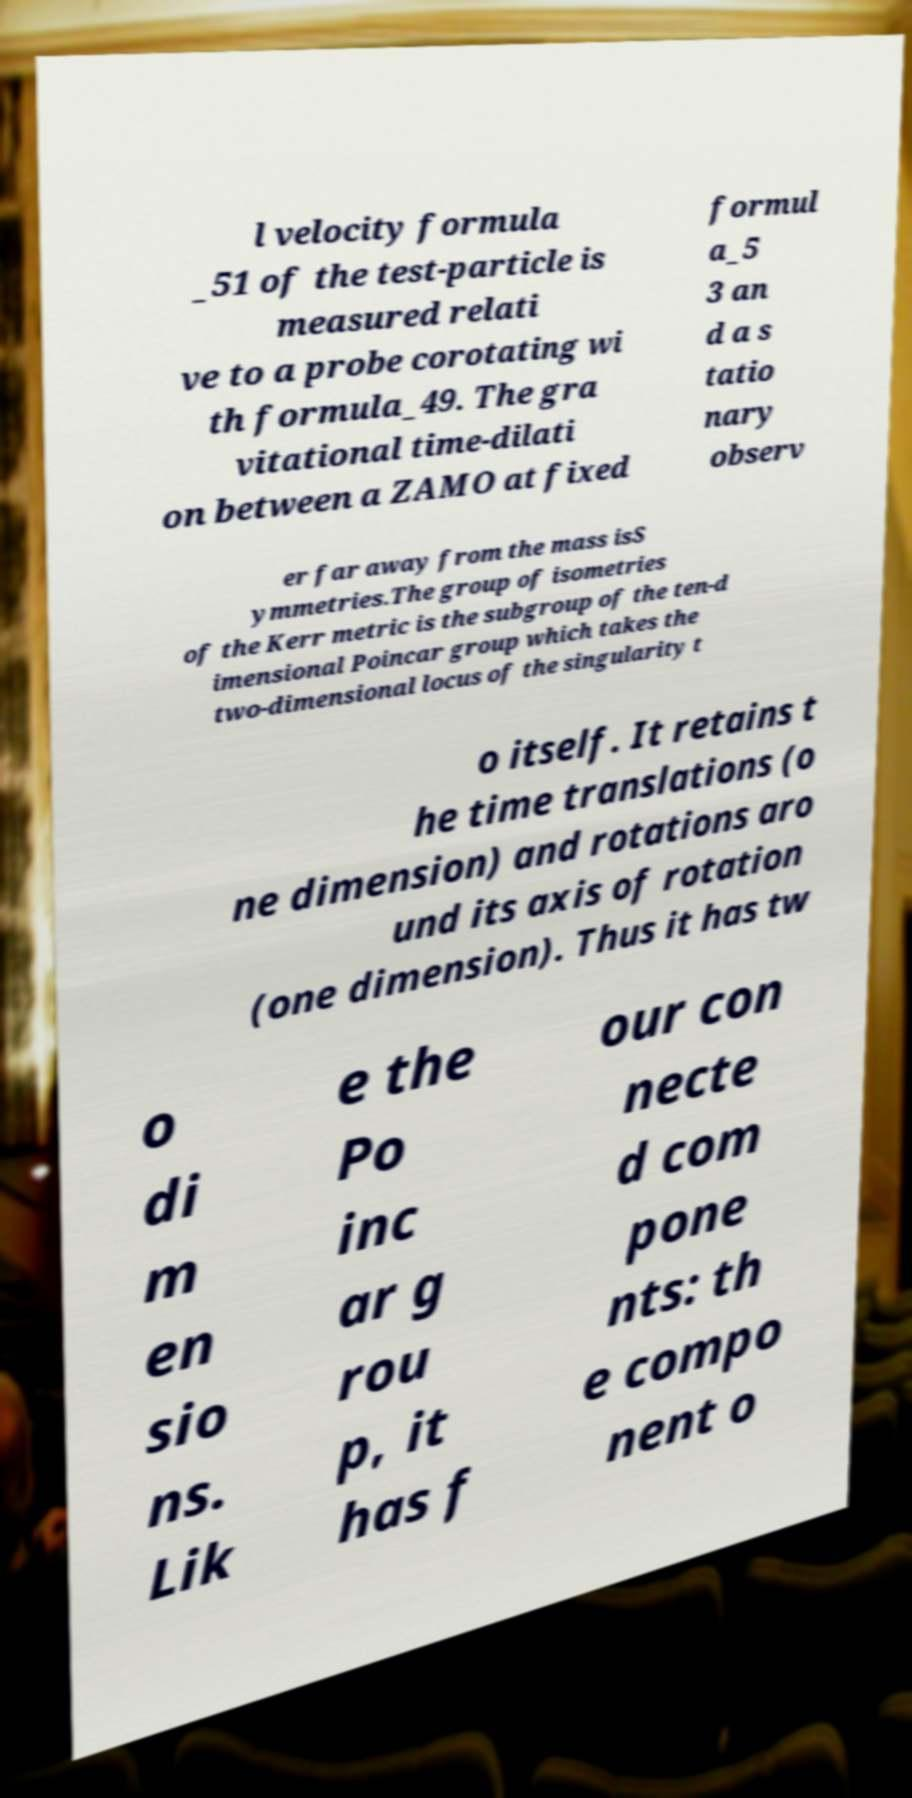Can you read and provide the text displayed in the image?This photo seems to have some interesting text. Can you extract and type it out for me? l velocity formula _51 of the test-particle is measured relati ve to a probe corotating wi th formula_49. The gra vitational time-dilati on between a ZAMO at fixed formul a_5 3 an d a s tatio nary observ er far away from the mass isS ymmetries.The group of isometries of the Kerr metric is the subgroup of the ten-d imensional Poincar group which takes the two-dimensional locus of the singularity t o itself. It retains t he time translations (o ne dimension) and rotations aro und its axis of rotation (one dimension). Thus it has tw o di m en sio ns. Lik e the Po inc ar g rou p, it has f our con necte d com pone nts: th e compo nent o 